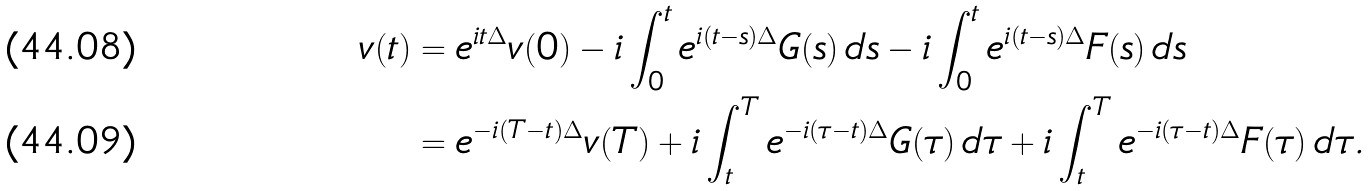<formula> <loc_0><loc_0><loc_500><loc_500>v ( t ) & = e ^ { i t \Delta } v ( 0 ) - i \int _ { 0 } ^ { t } e ^ { i ( t - s ) \Delta } G ( s ) \, d s - i \int _ { 0 } ^ { t } e ^ { i ( t - s ) \Delta } F ( s ) \, d s \\ & = e ^ { - i ( T - t ) \Delta } v ( T ) + i \int _ { t } ^ { T } e ^ { - i ( \tau - t ) \Delta } G ( \tau ) \, d \tau + i \int _ { t } ^ { T } e ^ { - i ( \tau - t ) \Delta } F ( \tau ) \, d \tau .</formula> 